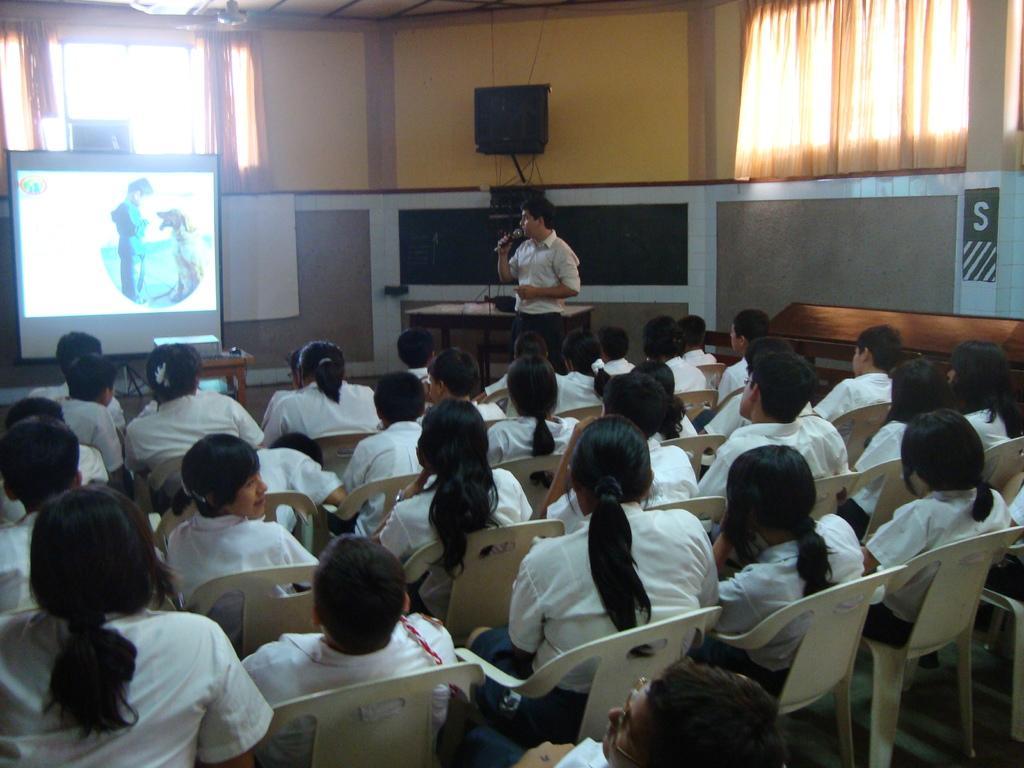Could you give a brief overview of what you see in this image? Here we can see some persons are sitting on the chairs. There is a man talking on the mike. This is screen. On the background there is a wall. And this is curtain. There is a table and this is projector. 